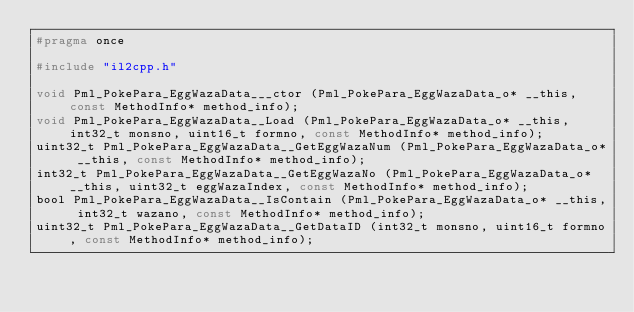<code> <loc_0><loc_0><loc_500><loc_500><_C_>#pragma once

#include "il2cpp.h"

void Pml_PokePara_EggWazaData___ctor (Pml_PokePara_EggWazaData_o* __this, const MethodInfo* method_info);
void Pml_PokePara_EggWazaData__Load (Pml_PokePara_EggWazaData_o* __this, int32_t monsno, uint16_t formno, const MethodInfo* method_info);
uint32_t Pml_PokePara_EggWazaData__GetEggWazaNum (Pml_PokePara_EggWazaData_o* __this, const MethodInfo* method_info);
int32_t Pml_PokePara_EggWazaData__GetEggWazaNo (Pml_PokePara_EggWazaData_o* __this, uint32_t eggWazaIndex, const MethodInfo* method_info);
bool Pml_PokePara_EggWazaData__IsContain (Pml_PokePara_EggWazaData_o* __this, int32_t wazano, const MethodInfo* method_info);
uint32_t Pml_PokePara_EggWazaData__GetDataID (int32_t monsno, uint16_t formno, const MethodInfo* method_info);
</code> 